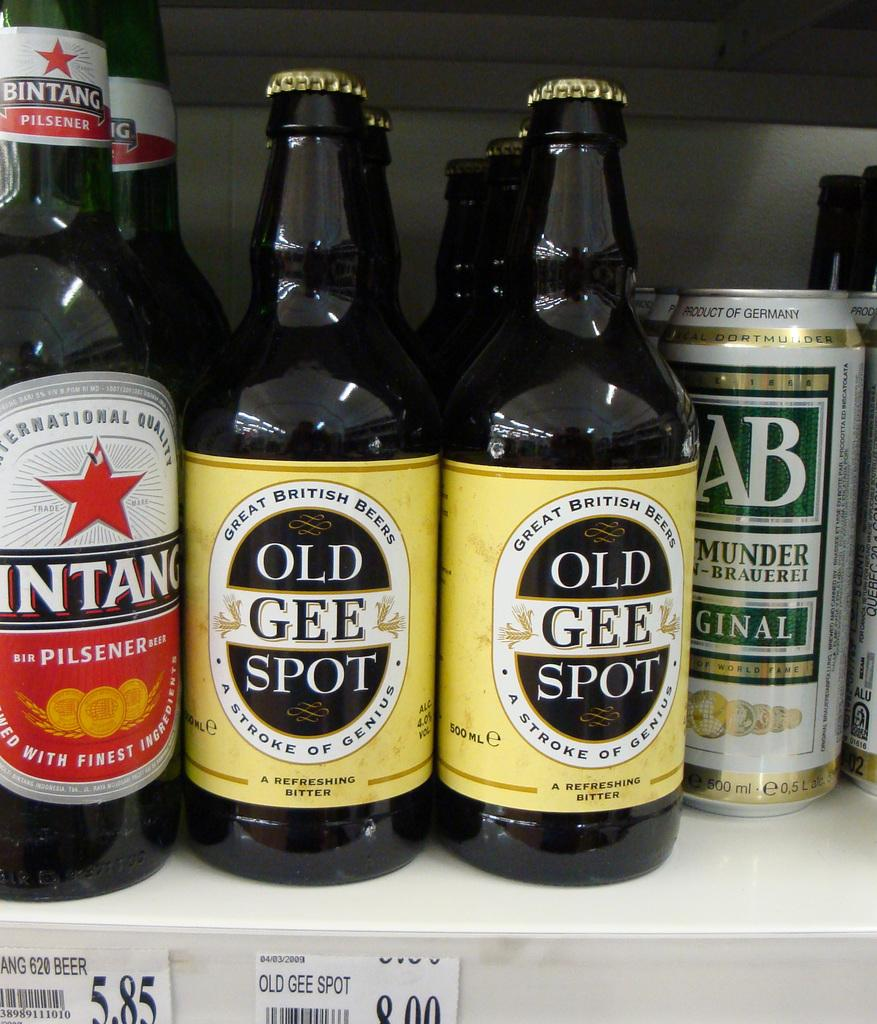<image>
Relay a brief, clear account of the picture shown. Bottles and cans of beer sitting by each other with the bottles in front saying OLD GEE SPOT. 